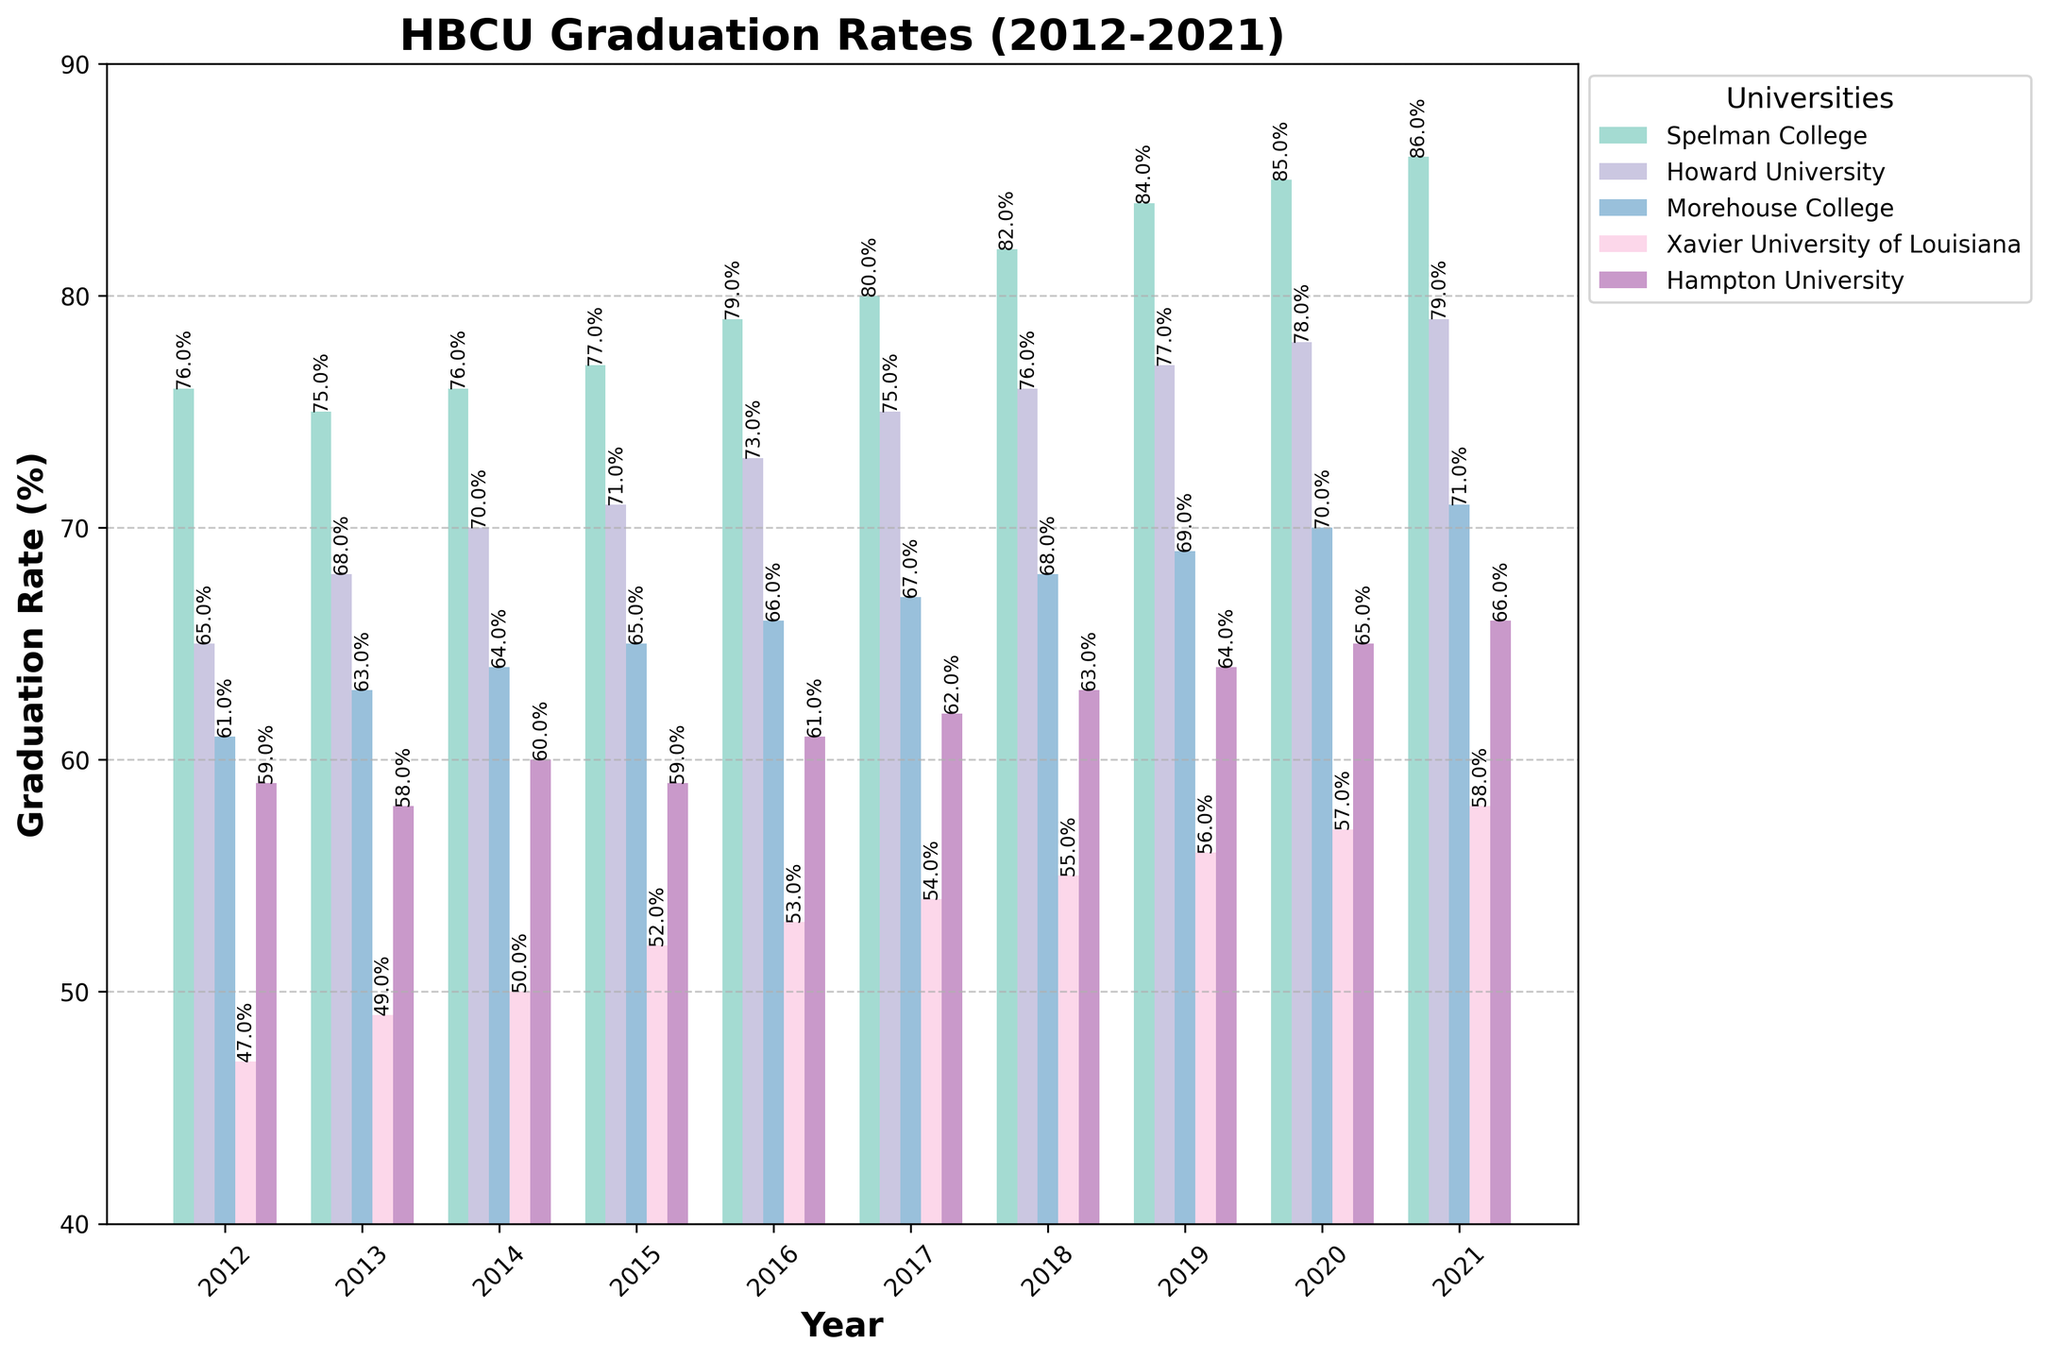How much did the graduation rate for Spelman College increase from 2012 to 2021? First, note the graduation rates for Spelman College in 2012 and 2021, which are 76% and 86%, respectively. Subtract the 2012 rate from the 2021 rate: 86% - 76% = 10%.
Answer: 10% Which university had the highest graduation rate in 2021? Look at the bars for the year 2021 and find the one with the highest value. Spelman College has the highest rate at 86%.
Answer: Spelman College In which year did Howard University surpass a 70% graduation rate for the first time? Refer to the bars representing Howard University each year. Howard University surpasses 70% for the first time in 2014 with a 70% rate.
Answer: 2014 What is the trend in graduation rates for Morehouse College from 2012 to 2021? Observe the heights of the Morehouse College bars over the years. The rate shows a consistent upward trend from 61% in 2012 to 71% in 2021.
Answer: Increasing Between 2014 and 2019, how much did the graduation rate for Xavier University of Louisiana improve? Note the rates for Xavier University of Louisiana in 2014 and 2019, which are 50% and 56%, respectively. Calculate the difference: 56% - 50% = 6%.
Answer: 6% Which university had the lowest graduation rate in 2012, and what was it? Look at the bars for each university in 2012 and find the shortest one. Xavier University of Louisiana had the lowest rate at 47%.
Answer: Xavier University of Louisiana, 47% How does the graduation rate of Hampton University in 2016 compare to Spelman College in the same year? Compare the two bars for 2016. Hampton University has a 61% rate, while Spelman College has a 79% rate, indicating Spelman's rate is higher.
Answer: Spelman College is higher What is the average graduation rate for Xavier University of Louisiana from 2012 to 2021? Sum the graduation rates over the years: 47 + 49 + 50 + 52 + 53 + 54 + 55 + 56 + 57 + 58 = 531. Then, divide by the number of years: 531 / 10 = 53.1%.
Answer: 53.1% What is the difference between the highest and lowest graduation rates for Spelman College across all years? Identify the highest and lowest rates for Spelman College, which are 86% in 2021 and 75% in 2013. Calculate the difference: 86% - 75% = 11%.
Answer: 11% Which universities consistently have higher graduation rates than Morehouse College every year? Compare yearly rates for each university against Morehouse College. Both Spelman College and Howard University have higher rates every year.
Answer: Spelman College and Howard University 